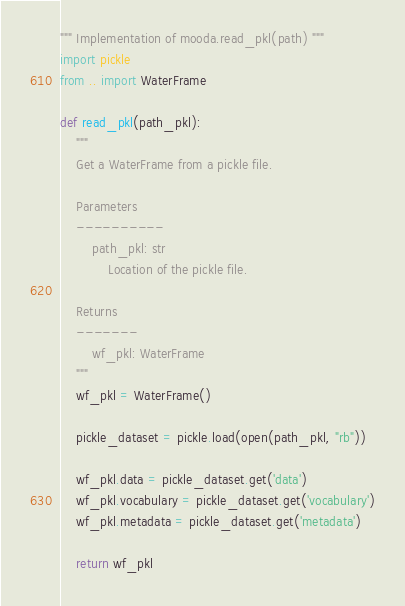Convert code to text. <code><loc_0><loc_0><loc_500><loc_500><_Python_>""" Implementation of mooda.read_pkl(path) """
import pickle
from .. import WaterFrame

def read_pkl(path_pkl):
    """
    Get a WaterFrame from a pickle file.

    Parameters
    ----------
        path_pkl: str
            Location of the pickle file.

    Returns
    -------
        wf_pkl: WaterFrame
    """
    wf_pkl = WaterFrame()

    pickle_dataset = pickle.load(open(path_pkl, "rb"))

    wf_pkl.data = pickle_dataset.get('data')
    wf_pkl.vocabulary = pickle_dataset.get('vocabulary')
    wf_pkl.metadata = pickle_dataset.get('metadata')

    return wf_pkl
</code> 